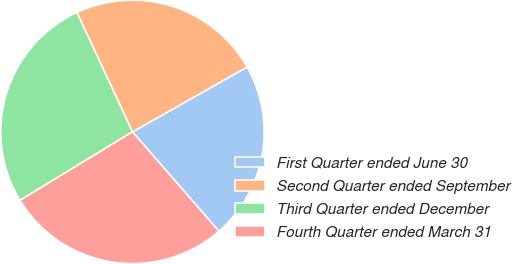Convert chart to OTSL. <chart><loc_0><loc_0><loc_500><loc_500><pie_chart><fcel>First Quarter ended June 30<fcel>Second Quarter ended September<fcel>Third Quarter ended December<fcel>Fourth Quarter ended March 31<nl><fcel>21.79%<fcel>23.74%<fcel>26.77%<fcel>27.69%<nl></chart> 